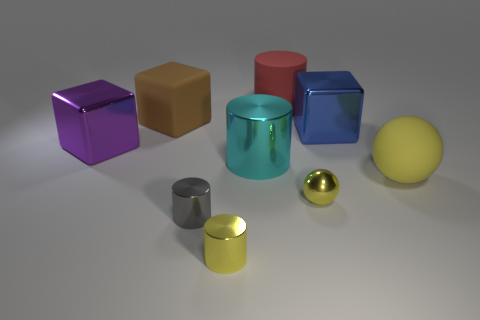How big is the metal object that is in front of the large purple block and to the right of the red thing?
Keep it short and to the point. Small. Is the number of metallic things that are to the right of the big red matte object greater than the number of small gray objects that are to the right of the blue shiny object?
Your answer should be very brief. Yes. There is another object that is the same shape as the yellow rubber thing; what color is it?
Offer a very short reply. Yellow. There is a rubber object in front of the purple metallic cube; does it have the same color as the tiny sphere?
Offer a terse response. Yes. What number of purple objects are there?
Keep it short and to the point. 1. Does the big thing that is to the right of the blue metal thing have the same material as the red cylinder?
Offer a very short reply. Yes. There is a cylinder that is behind the block that is to the left of the big brown matte thing; what number of tiny cylinders are behind it?
Offer a terse response. 0. The yellow metal ball is what size?
Provide a succinct answer. Small. Is the tiny sphere the same color as the large matte cylinder?
Make the answer very short. No. What size is the yellow metal object right of the big cyan metal thing?
Offer a very short reply. Small. 